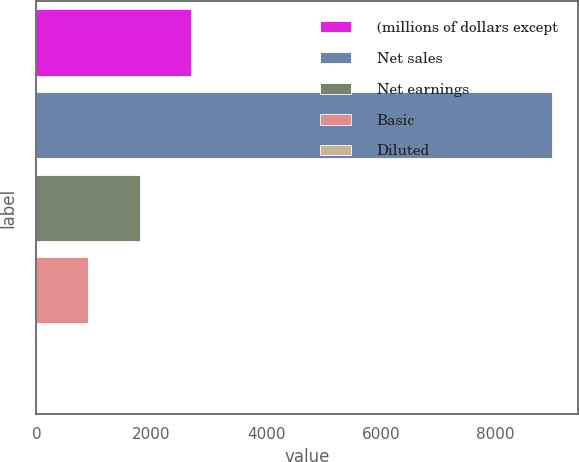<chart> <loc_0><loc_0><loc_500><loc_500><bar_chart><fcel>(millions of dollars except<fcel>Net sales<fcel>Net earnings<fcel>Basic<fcel>Diluted<nl><fcel>2695.33<fcel>8977.7<fcel>1797.85<fcel>900.37<fcel>2.89<nl></chart> 